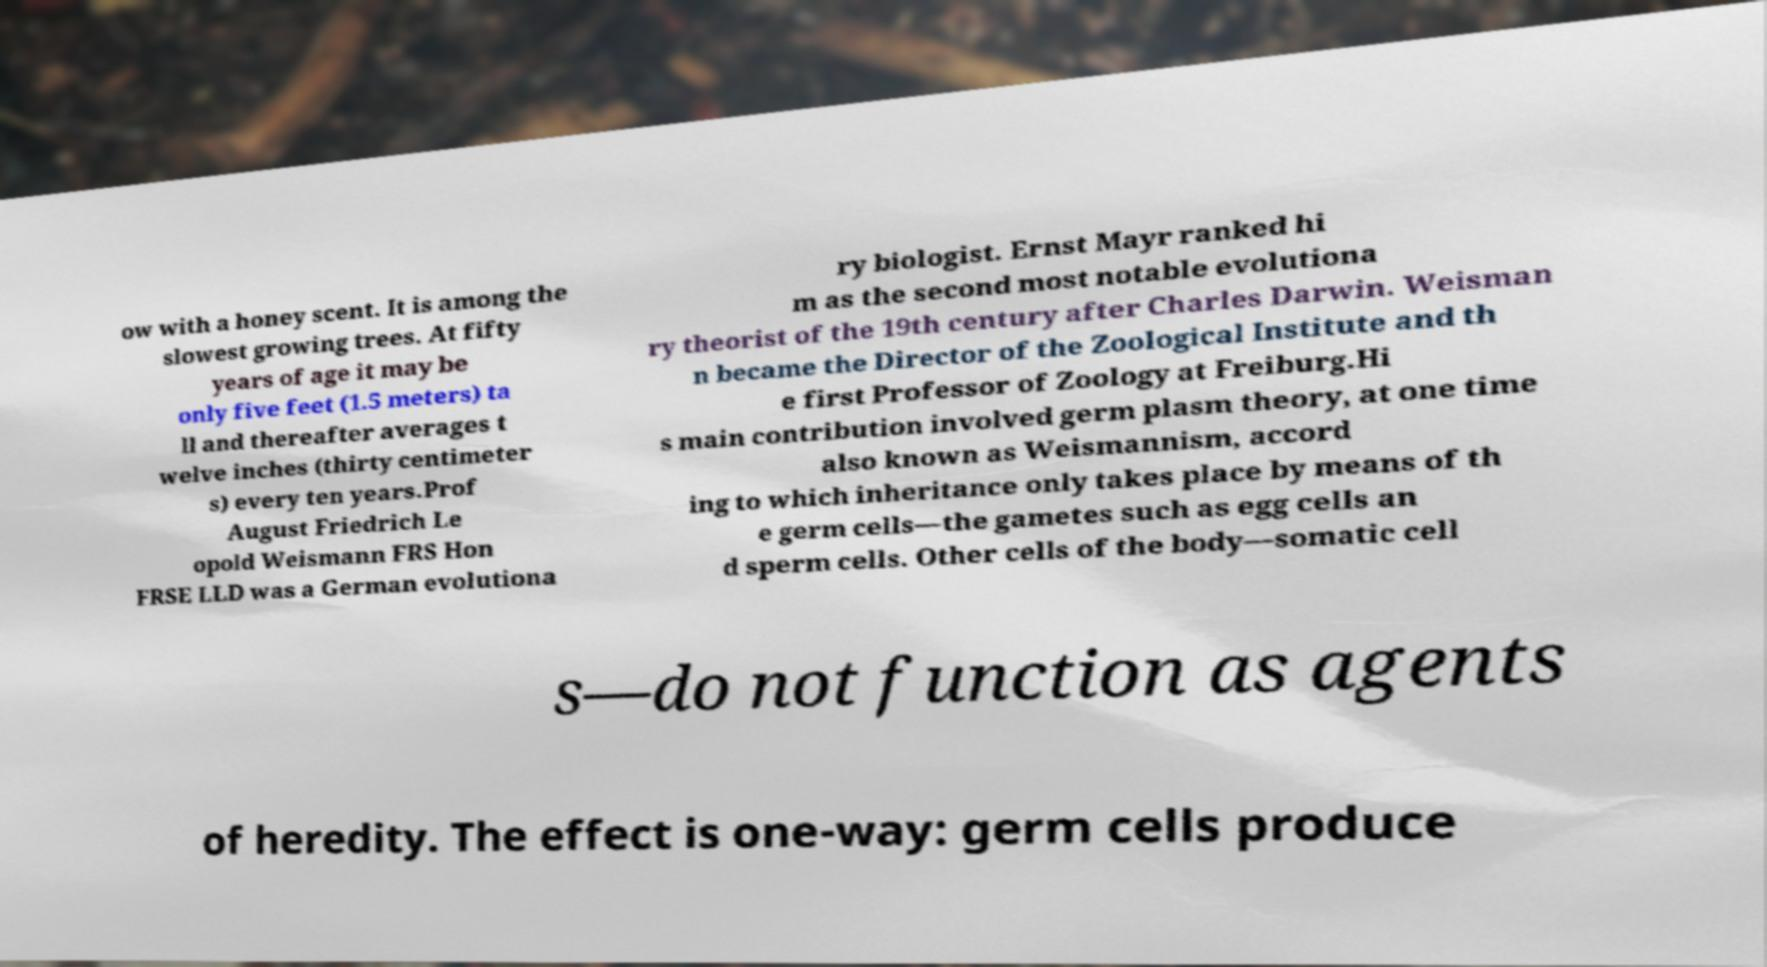Can you read and provide the text displayed in the image?This photo seems to have some interesting text. Can you extract and type it out for me? ow with a honey scent. It is among the slowest growing trees. At fifty years of age it may be only five feet (1.5 meters) ta ll and thereafter averages t welve inches (thirty centimeter s) every ten years.Prof August Friedrich Le opold Weismann FRS Hon FRSE LLD was a German evolutiona ry biologist. Ernst Mayr ranked hi m as the second most notable evolutiona ry theorist of the 19th century after Charles Darwin. Weisman n became the Director of the Zoological Institute and th e first Professor of Zoology at Freiburg.Hi s main contribution involved germ plasm theory, at one time also known as Weismannism, accord ing to which inheritance only takes place by means of th e germ cells—the gametes such as egg cells an d sperm cells. Other cells of the body—somatic cell s—do not function as agents of heredity. The effect is one-way: germ cells produce 